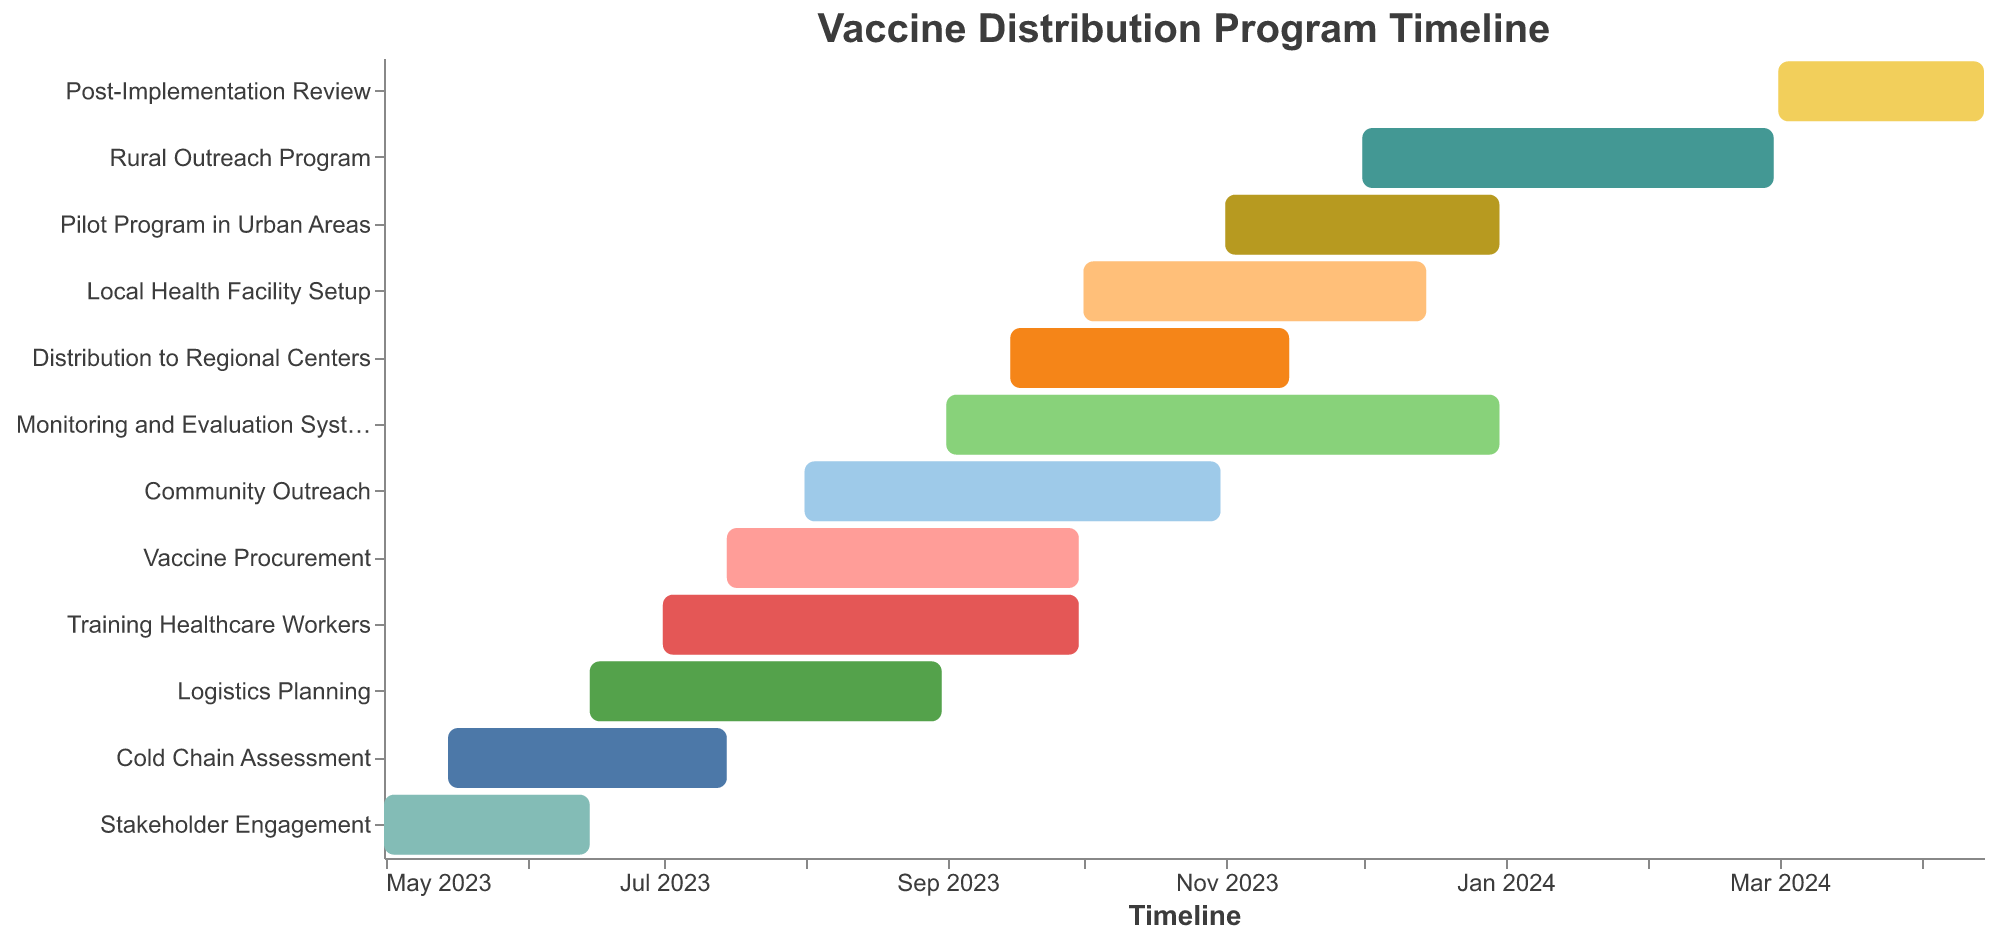What is the total duration of the "Cold Chain Assessment" task? The "Cold Chain Assessment" task starts on May 15, 2023 and ends on July 15, 2023. By counting the days between these dates, we see that the task lasts for 62 days, which is also provided in the chart under the Duration column.
Answer: 62 days Which task has the longest duration? By examining the durations of all tasks, "Monitoring and Evaluation System" has a duration of 122 days, which is the longest among the listed tasks.
Answer: Monitoring and Evaluation System When does the "Rural Outreach Program" start and end? The Gantt chart shows that the "Rural Outreach Program" starts on December 1, 2023 and ends on February 29, 2024.
Answer: Starts: Dec 1, 2023; Ends: Feb 29, 2024 What tasks are happening in August 2023? Tasks happening in August 2023 include "Training Healthcare Workers", "Logistics Planning", "Community Outreach", and "Vaccine Procurement". Each of these tasks covers the month of August either partially or fully according to their start and end dates.
Answer: Training Healthcare Workers, Logistics Planning, Community Outreach, Vaccine Procurement Which task overlaps with the "Distribution to Regional Centers" and for how long do they overlap? The "Distribution to Regional Centers" task overlaps with the "Monitoring and Evaluation System" task. "Distribution to Regional Centers" runs from September 15, 2023 to November 15, 2023, while "Monitoring and Evaluation System" runs from September 1, 2023 to December 31, 2023. The overlap starts on September 15, 2023 and lasts until November 15, 2023, resulting in a 62-day overlap.
Answer: Monitoring and Evaluation System; 62 days What is the total duration of all tasks combined? Adding the durations of all tasks: 46 (Stakeholder Engagement) + 62 (Cold Chain Assessment) + 92 (Training Healthcare Workers) + 78 (Logistics Planning) + 92 (Community Outreach) + 78 (Vaccine Procurement) + 62 (Distribution to Regional Centers) + 76 (Local Health Facility Setup) + 122 (Monitoring and Evaluation System) + 61 (Pilot Program in Urban Areas) + 91 (Rural Outreach Program) + 46 (Post-Implementation Review) = 906 days.
Answer: 906 days Between which months does the "Pilot Program in Urban Areas" take place? The "Pilot Program in Urban Areas" starts on November 1, 2023 and ends on December 31, 2023. Therefore, it takes place in the months of November and December 2023.
Answer: November and December 2023 